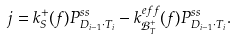<formula> <loc_0><loc_0><loc_500><loc_500>j = k ^ { + } _ { S } ( f ) P ^ { s s } _ { D _ { i - 1 } \cdot T _ { i } } - k _ { \mathcal { B } ^ { + } _ { T } } ^ { e f f } ( f ) P ^ { s s } _ { D _ { i - 1 } \cdot T _ { i } } .</formula> 